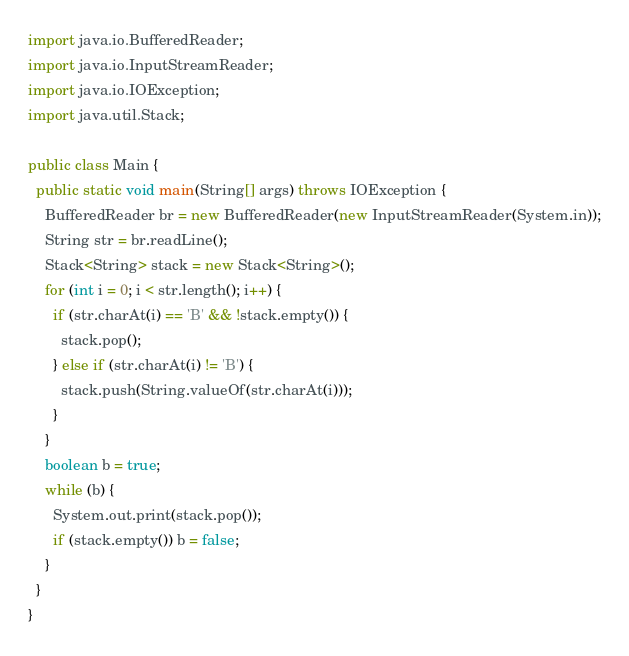Convert code to text. <code><loc_0><loc_0><loc_500><loc_500><_Java_>import java.io.BufferedReader;
import java.io.InputStreamReader;
import java.io.IOException;
import java.util.Stack;

public class Main {
  public static void main(String[] args) throws IOException {
    BufferedReader br = new BufferedReader(new InputStreamReader(System.in));
    String str = br.readLine();
    Stack<String> stack = new Stack<String>();
    for (int i = 0; i < str.length(); i++) {
      if (str.charAt(i) == 'B' && !stack.empty()) {
        stack.pop();
      } else if (str.charAt(i) != 'B') {
        stack.push(String.valueOf(str.charAt(i)));
      }
    }
    boolean b = true;
    while (b) {
      System.out.print(stack.pop());
      if (stack.empty()) b = false;
    }
  }
}</code> 